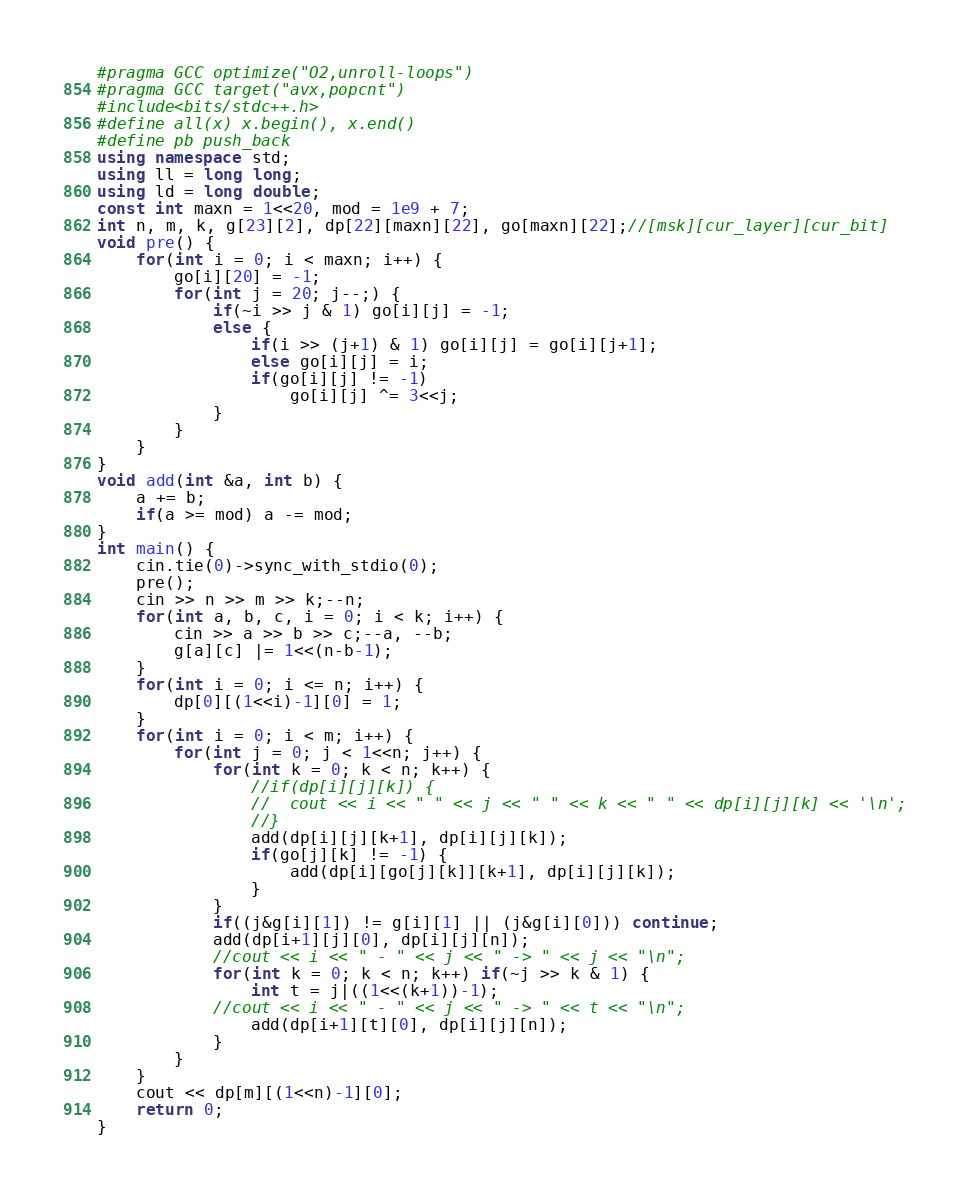<code> <loc_0><loc_0><loc_500><loc_500><_C++_>#pragma GCC optimize("O2,unroll-loops")
#pragma GCC target("avx,popcnt")
#include<bits/stdc++.h>
#define all(x) x.begin(), x.end()
#define pb push_back
using namespace std;
using ll = long long;
using ld = long double;
const int maxn = 1<<20, mod = 1e9 + 7;
int n, m, k, g[23][2], dp[22][maxn][22], go[maxn][22];//[msk][cur_layer][cur_bit]
void pre() {
	for(int i = 0; i < maxn; i++) {
		go[i][20] = -1;
		for(int j = 20; j--;) {
			if(~i >> j & 1) go[i][j] = -1;
			else {
				if(i >> (j+1) & 1) go[i][j] = go[i][j+1];
				else go[i][j] = i;
				if(go[i][j] != -1)
					go[i][j] ^= 3<<j;
			}
		}
	}
}
void add(int &a, int b) {
	a += b;
	if(a >= mod) a -= mod;
}
int main() {
	cin.tie(0)->sync_with_stdio(0);
	pre();
	cin >> n >> m >> k;--n;
	for(int a, b, c, i = 0; i < k; i++) {
		cin >> a >> b >> c;--a, --b;
		g[a][c] |= 1<<(n-b-1);
	}
	for(int i = 0; i <= n; i++) {
		dp[0][(1<<i)-1][0] = 1;
	}
	for(int i = 0; i < m; i++) {
		for(int j = 0; j < 1<<n; j++) {
			for(int k = 0; k < n; k++) {
				//if(dp[i][j][k]) {
				//	cout << i << " " << j << " " << k << " " << dp[i][j][k] << '\n';
				//}
				add(dp[i][j][k+1], dp[i][j][k]);
				if(go[j][k] != -1) {
					add(dp[i][go[j][k]][k+1], dp[i][j][k]);
				}
			}
			if((j&g[i][1]) != g[i][1] || (j&g[i][0])) continue; 
			add(dp[i+1][j][0], dp[i][j][n]);
			//cout << i << " - " << j << " -> " << j << "\n";
			for(int k = 0; k < n; k++) if(~j >> k & 1) {
				int t = j|((1<<(k+1))-1);
			//cout << i << " - " << j << " -> " << t << "\n";
				add(dp[i+1][t][0], dp[i][j][n]);
			}
		}
	}
	cout << dp[m][(1<<n)-1][0];
	return 0;
}
</code> 